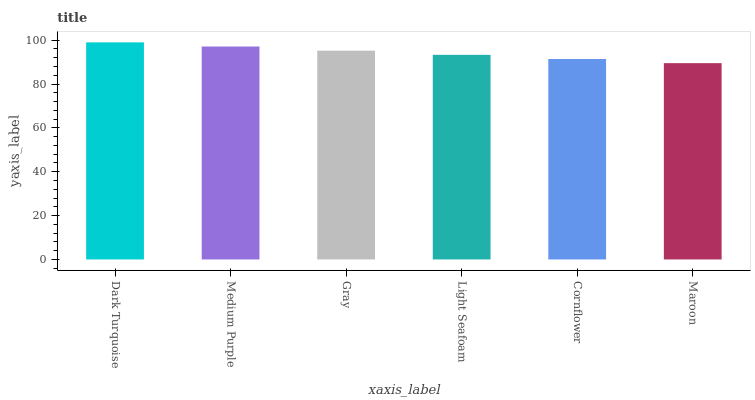Is Medium Purple the minimum?
Answer yes or no. No. Is Medium Purple the maximum?
Answer yes or no. No. Is Dark Turquoise greater than Medium Purple?
Answer yes or no. Yes. Is Medium Purple less than Dark Turquoise?
Answer yes or no. Yes. Is Medium Purple greater than Dark Turquoise?
Answer yes or no. No. Is Dark Turquoise less than Medium Purple?
Answer yes or no. No. Is Gray the high median?
Answer yes or no. Yes. Is Light Seafoam the low median?
Answer yes or no. Yes. Is Dark Turquoise the high median?
Answer yes or no. No. Is Medium Purple the low median?
Answer yes or no. No. 